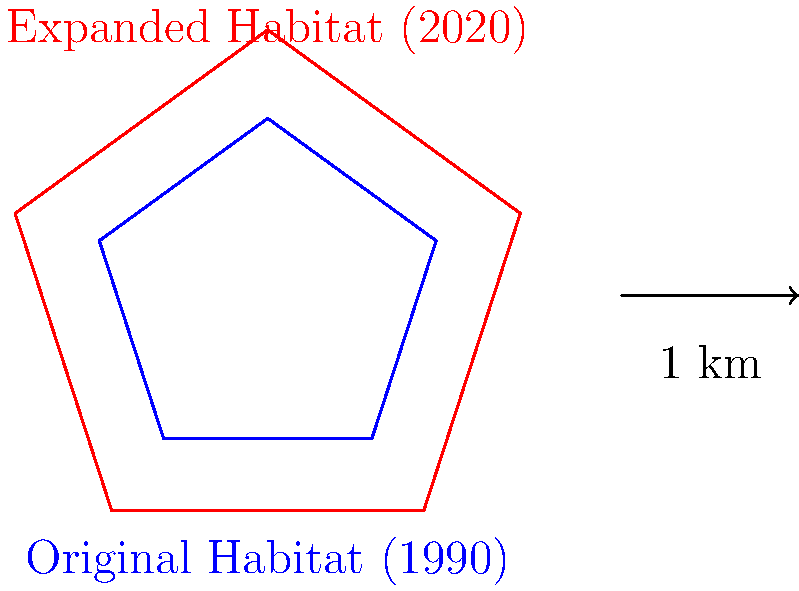A protected habitat for the endangered California Condor was established in 1990. Due to conservation efforts, the habitat's perimeter was expanded by 50% by 2020. If the original habitat was a regular pentagon with a perimeter of 15 km, what is the perimeter of the expanded habitat in 2020? How does this expansion reflect the growing awareness of environmental conservation over time? To solve this problem, we'll follow these steps:

1. Understand the given information:
   - The original habitat was a regular pentagon
   - The original perimeter was 15 km
   - The habitat expanded by 50% by 2020

2. Calculate the expanded perimeter:
   - 50% increase means multiplying by 1.5
   - New perimeter = Original perimeter × 1.5
   - New perimeter = 15 km × 1.5 = 22.5 km

3. Reflect on the environmental implications:
   - The expansion of the habitat by 50% over 30 years (1990 to 2020) demonstrates a significant commitment to conservation.
   - This growth reflects an increased understanding of the California Condor's habitat needs and the importance of preserving larger, connected areas for endangered species.
   - The expansion also suggests growing public and governmental support for environmental protection measures over time.
   - As a history teacher, we can observe how this change represents a shift in societal values and priorities regarding wildlife conservation from 1990 to 2020.
Answer: 22.5 km 